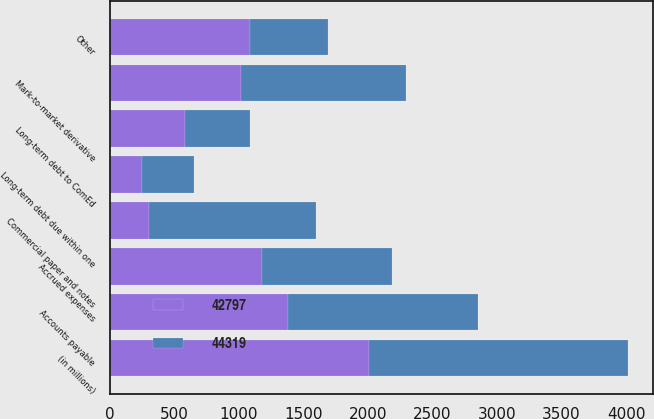<chart> <loc_0><loc_0><loc_500><loc_500><stacked_bar_chart><ecel><fcel>(in millions)<fcel>Commercial paper and notes<fcel>Long-term debt due within one<fcel>Long-term debt to ComEd<fcel>Accounts payable<fcel>Mark-to-market derivative<fcel>Accrued expenses<fcel>Other<nl><fcel>42797<fcel>2006<fcel>305<fcel>248<fcel>581<fcel>1382<fcel>1015<fcel>1180<fcel>1084<nl><fcel>44319<fcel>2005<fcel>1290<fcel>407<fcel>507<fcel>1467<fcel>1282<fcel>1005<fcel>605<nl></chart> 